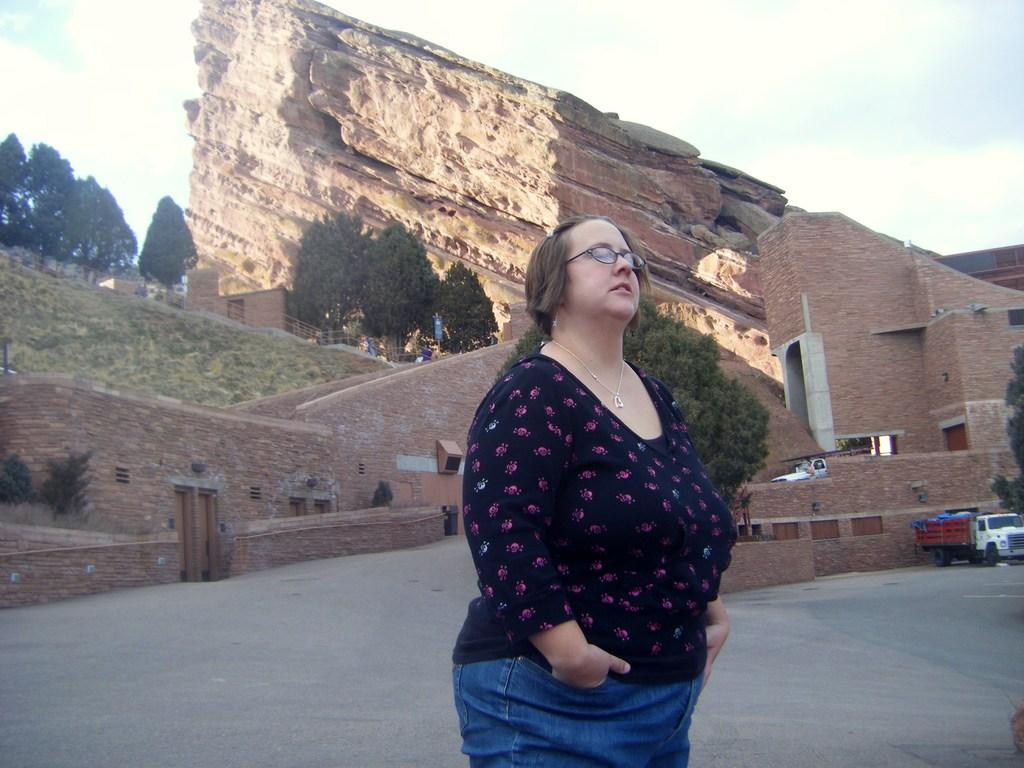In one or two sentences, can you explain what this image depicts? In this picture we can see a woman standing on the road, vehicle, fort, trees and in the background we can see the sky with clouds. 